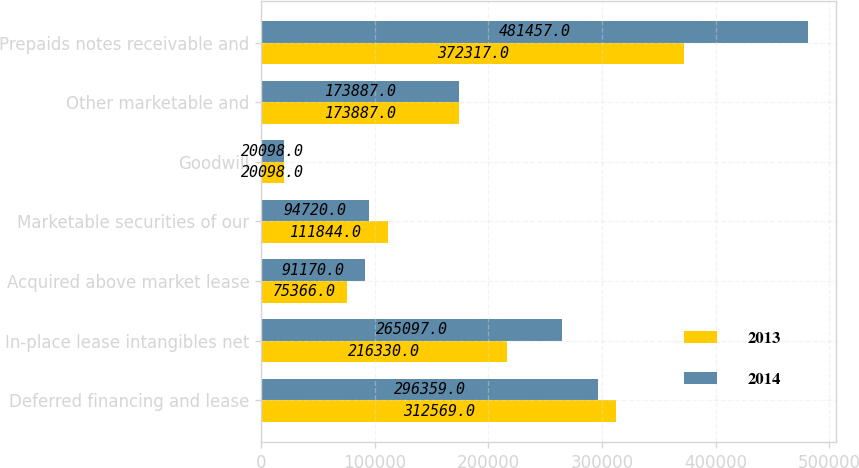<chart> <loc_0><loc_0><loc_500><loc_500><stacked_bar_chart><ecel><fcel>Deferred financing and lease<fcel>In-place lease intangibles net<fcel>Acquired above market lease<fcel>Marketable securities of our<fcel>Goodwill<fcel>Other marketable and<fcel>Prepaids notes receivable and<nl><fcel>2013<fcel>312569<fcel>216330<fcel>75366<fcel>111844<fcel>20098<fcel>173887<fcel>372317<nl><fcel>2014<fcel>296359<fcel>265097<fcel>91170<fcel>94720<fcel>20098<fcel>173887<fcel>481457<nl></chart> 